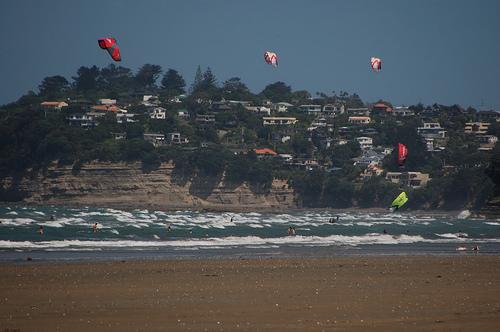How many kites are there?
Answer briefly. 5. What is the substance closest to the bottom of the picture?
Concise answer only. Sand. What is flying in the air?
Concise answer only. Kites. 